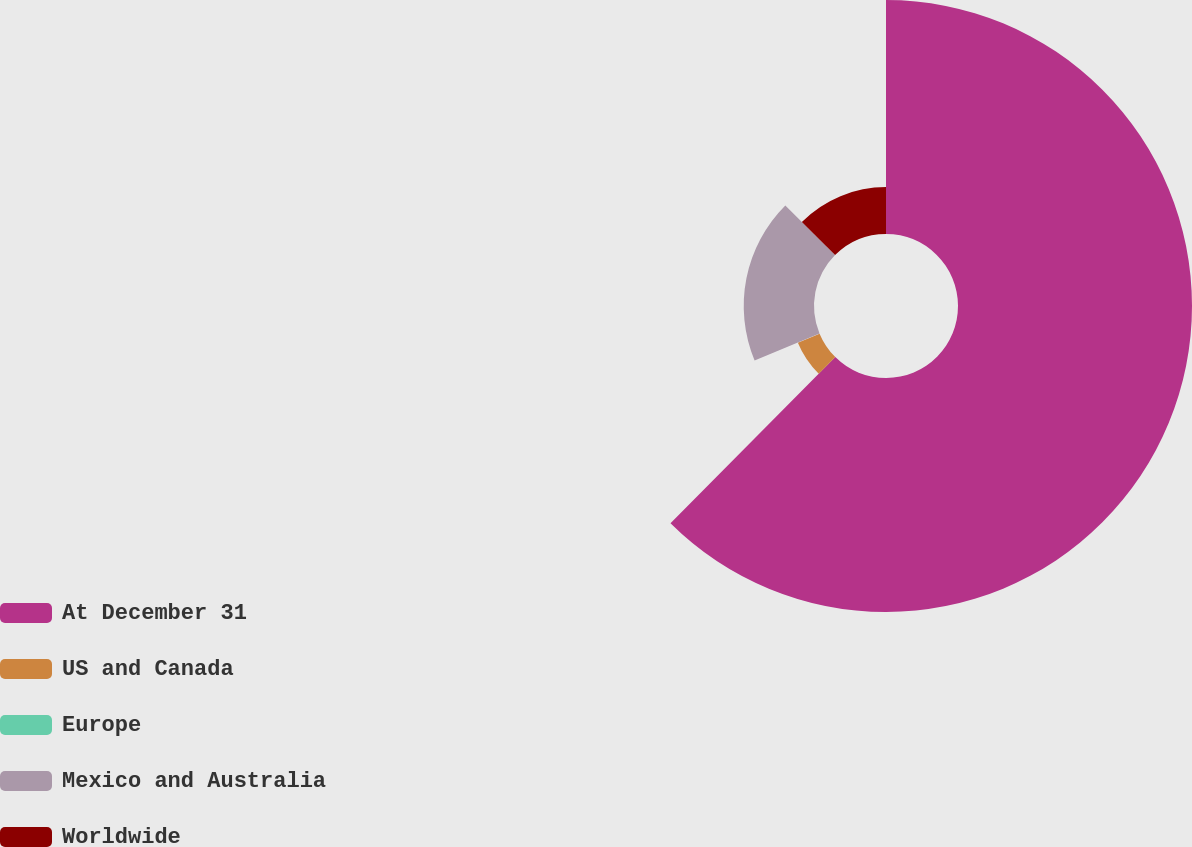Convert chart to OTSL. <chart><loc_0><loc_0><loc_500><loc_500><pie_chart><fcel>At December 31<fcel>US and Canada<fcel>Europe<fcel>Mexico and Australia<fcel>Worldwide<nl><fcel>62.43%<fcel>6.27%<fcel>0.03%<fcel>18.75%<fcel>12.51%<nl></chart> 